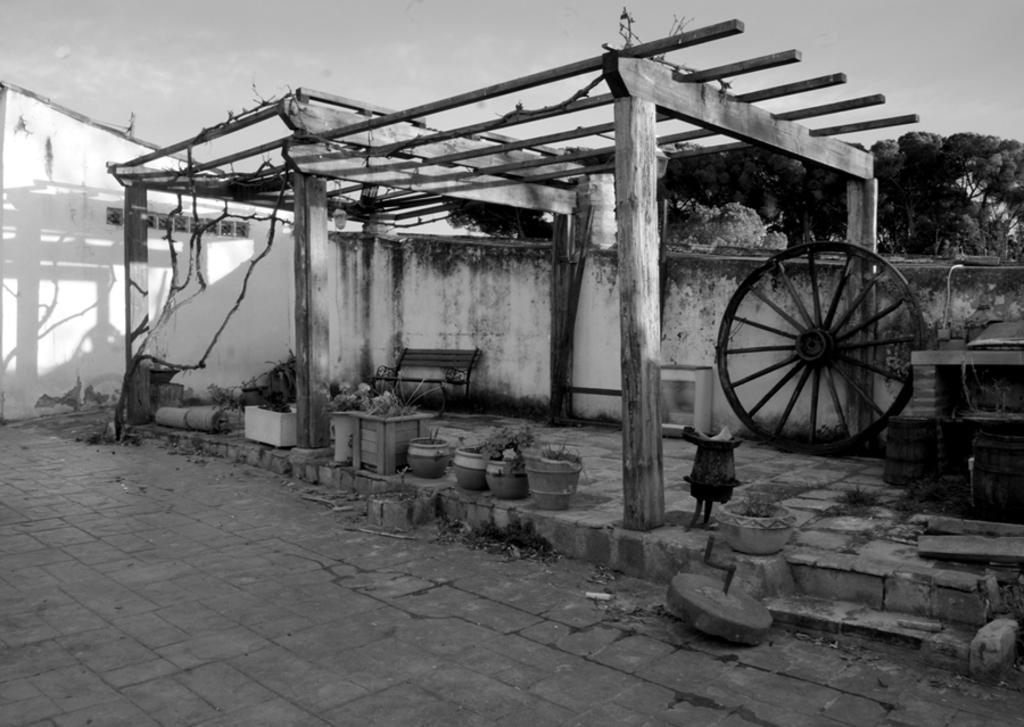What type of structure is visible in the image? There is a wooden shed in the image. What can be seen attached to the shed? There is a wheel in the image. What items are present near the shed? There are pots and other objects in the image. What can be seen in the distance behind the shed? There are trees in the background of the image. How is the image presented in terms of color? The image is in black and white. Where is the sofa located in the image? There is no sofa present in the image. Can you see a bat flying in the image? There is no bat visible in the image. 